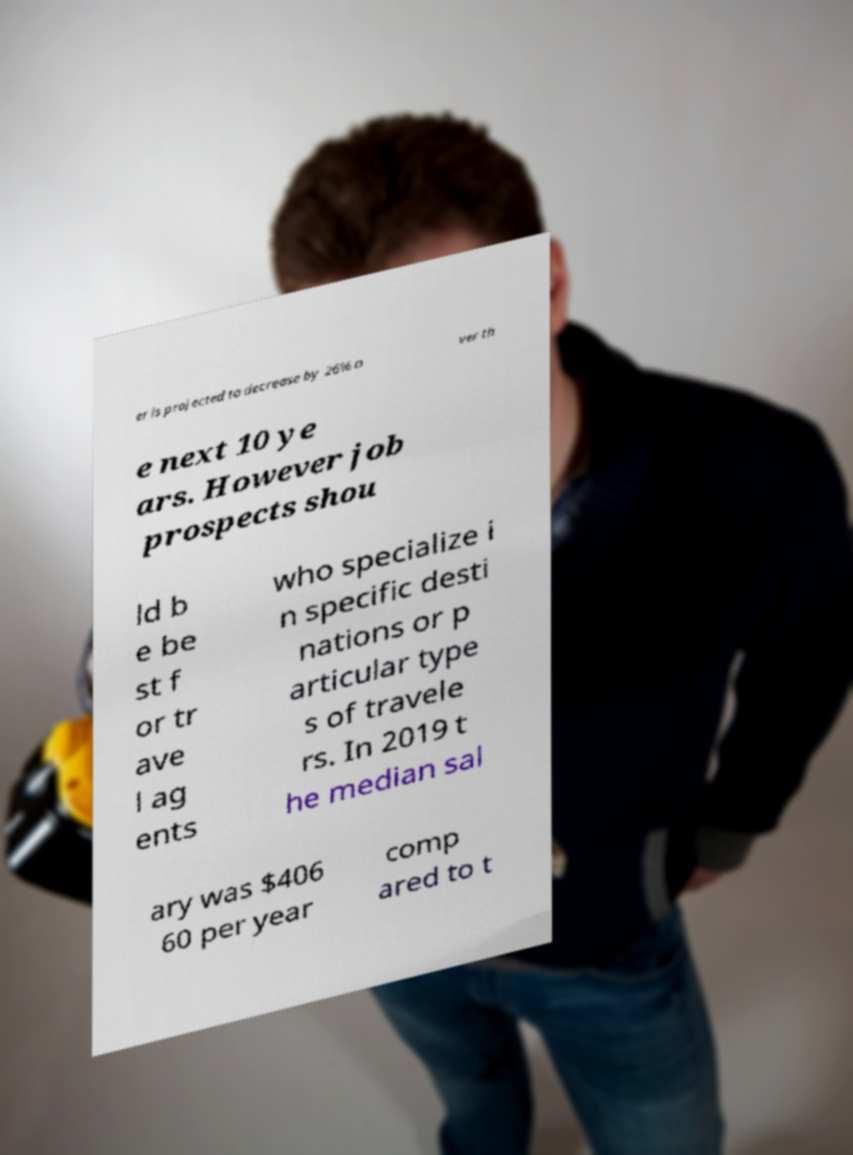I need the written content from this picture converted into text. Can you do that? er is projected to decrease by 26% o ver th e next 10 ye ars. However job prospects shou ld b e be st f or tr ave l ag ents who specialize i n specific desti nations or p articular type s of travele rs. In 2019 t he median sal ary was $406 60 per year comp ared to t 